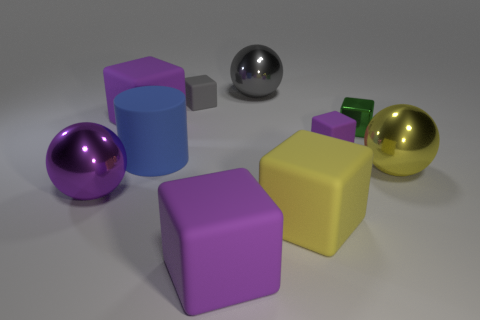Subtract all purple blocks. How many were subtracted if there are1purple blocks left? 2 Subtract all gray cubes. How many cubes are left? 5 Subtract all blue cylinders. How many purple cubes are left? 3 Subtract all metallic blocks. How many blocks are left? 5 Subtract all blue blocks. Subtract all purple spheres. How many blocks are left? 6 Subtract all cylinders. How many objects are left? 9 Subtract all large brown spheres. Subtract all tiny gray rubber blocks. How many objects are left? 9 Add 9 yellow metal balls. How many yellow metal balls are left? 10 Add 9 large blue shiny cubes. How many large blue shiny cubes exist? 9 Subtract 0 green spheres. How many objects are left? 10 